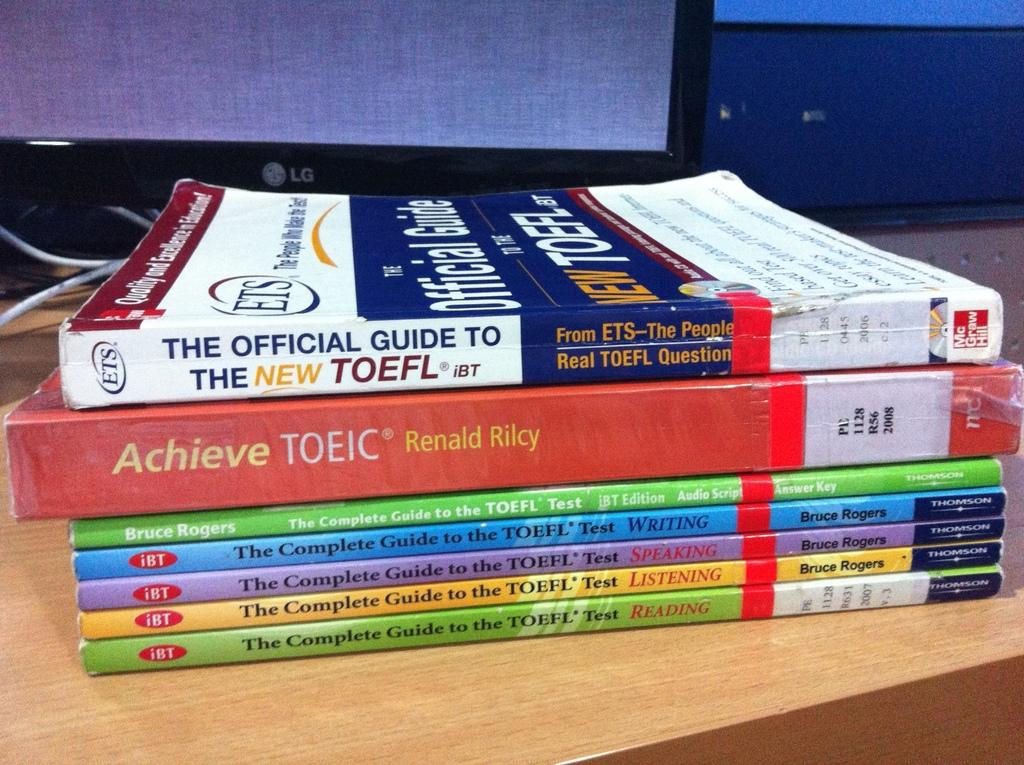<image>
Relay a brief, clear account of the picture shown. The official guide to the new TOEFL and Achieve TOEIC book. 